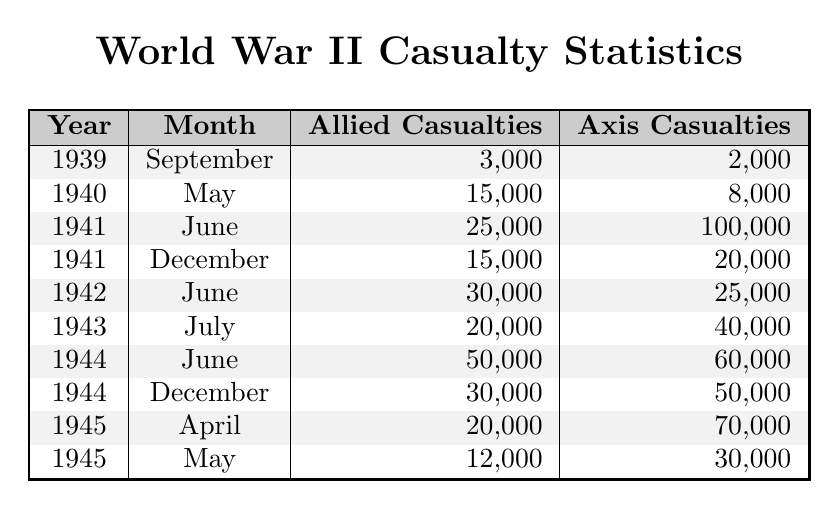What month and year had the highest Allied casualties? Looking at the table, the highest number of Allied casualties is 50,000, which occurred in June 1944.
Answer: June 1944 What was the total number of Axis casualties in 1945? Adding up the Axis casualties for 1945: 70,000 (April) + 30,000 (May) = 100,000.
Answer: 100,000 In which month during World War II did the Allied casualties first exceed 15,000? The data shows that Allied casualties first exceeded 15,000 in May 1940.
Answer: May 1940 How many more Allied casualties were there in June 1941 compared to December 1941? The Allied casualties in June 1941 were 25,000, and in December 1941 were 15,000. The difference is 25,000 - 15,000 = 10,000.
Answer: 10,000 What percentage of Allied casualties in June 1942 was there compared to June 1941? The Allied casualties in June 1942 were 30,000 and in June 1941 were 25,000. The percentage is (30,000/25,000) * 100 = 120%.
Answer: 120% Did the Axis suffer more casualties than the Allies in 1943? Yes, the Axis casualties in July 1943 were 40,000, while the Allied casualties were 20,000.
Answer: Yes Which year had the highest total of Allied casualties across the months listed? Adding the Allied casualties: 3,000 (Sept 1939) + 15,000 (May 1940) + 25,000 (June 1941) + 15,000 (Dec 1941) + 30,000 (June 1942) + 20,000 (July 1943) + 50,000 (June 1944) + 30,000 (Dec 1944) + 20,000 (April 1945) + 12,000 (May 1945) = 205,000. The year with the highest Allied casualties is 1944 with 80,000 (June + December).
Answer: 1944 What was the ratio of Allied to Axis casualties in June 1944? In June 1944, the Allied casualties were 50,000 and Axis casualties were 60,000. The ratio is 50,000:60,000, which simplifies to 5:6.
Answer: 5:6 How many months listed had Axis casualties above 50,000? In the table, August 1941 and March 1945 show Axis casualties of 100,000 and 70,000 respectively. Thus, there are two months with more than 50,000 casualties for the Axis.
Answer: 2 What is the median number of Allied casualties from the data provided? Ordering the Allied casualties: 3,000; 15,000; 15,000; 20,000; 25,000; 30,000; 30,000; 50,000; 20,000; 12,000 gives 25,000 as the 5th element in the sorted list. Median = (20,000 + 25,000) / 2 = 25,000.
Answer: 25,000 Which year had the least number of Axis casualties? Summing Axis casualties: 2,000 (1939) + 8,000 (1940) + 100,000 (1941) + 20,000 (1941) + 25,000 (1942) + 40,000 (1943) + 60,000 (1944) + 50,000 (1944) + 70,000 (1945) + 30,000 (1945) = 375,000. The year with the least total Axis casualties is 1939 with 2,000.
Answer: 1939 